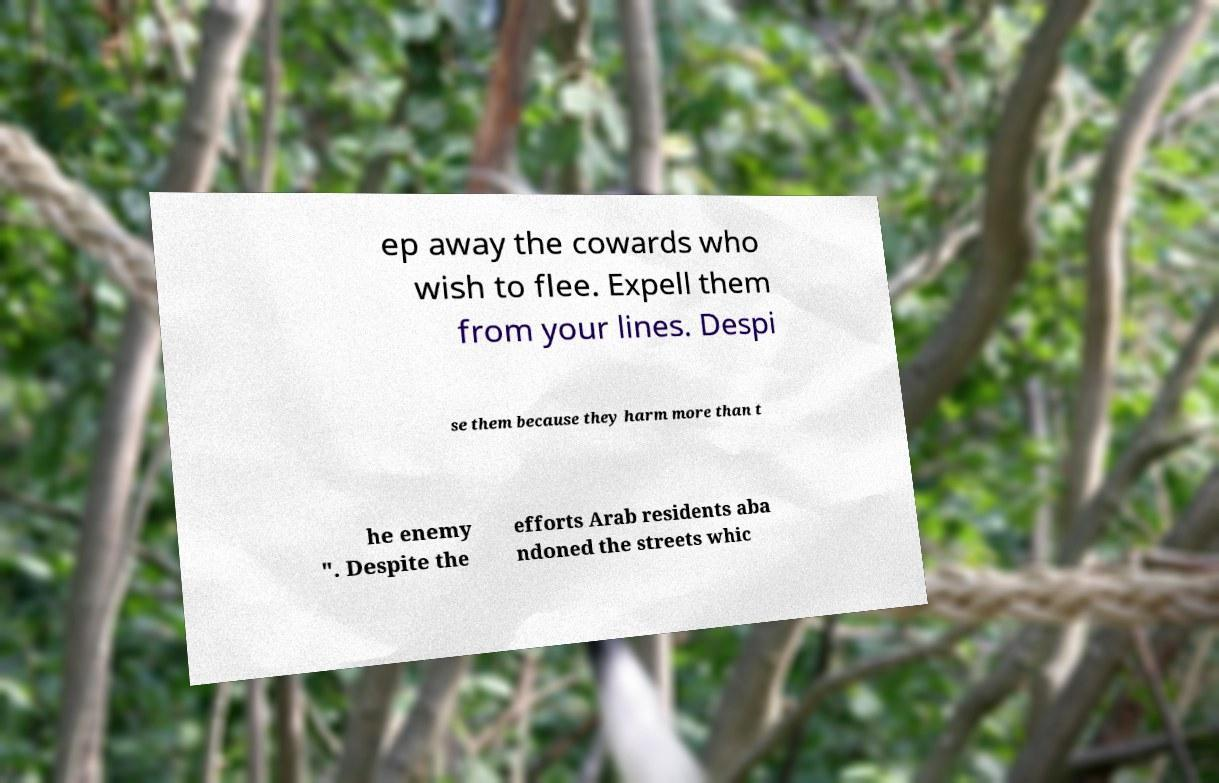What messages or text are displayed in this image? I need them in a readable, typed format. ep away the cowards who wish to flee. Expell them from your lines. Despi se them because they harm more than t he enemy ". Despite the efforts Arab residents aba ndoned the streets whic 